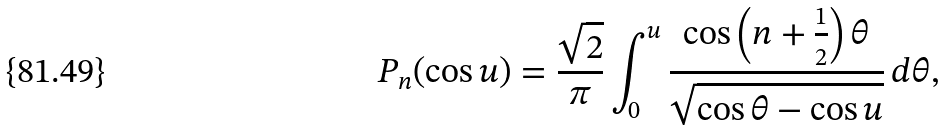Convert formula to latex. <formula><loc_0><loc_0><loc_500><loc_500>P _ { n } ( \cos u ) = \frac { \sqrt { 2 } } { \pi } \int _ { 0 } ^ { u } \frac { \cos \left ( n + \frac { 1 } { 2 } \right ) \theta } { \sqrt { \cos \theta - \cos u } } \, d \theta ,</formula> 